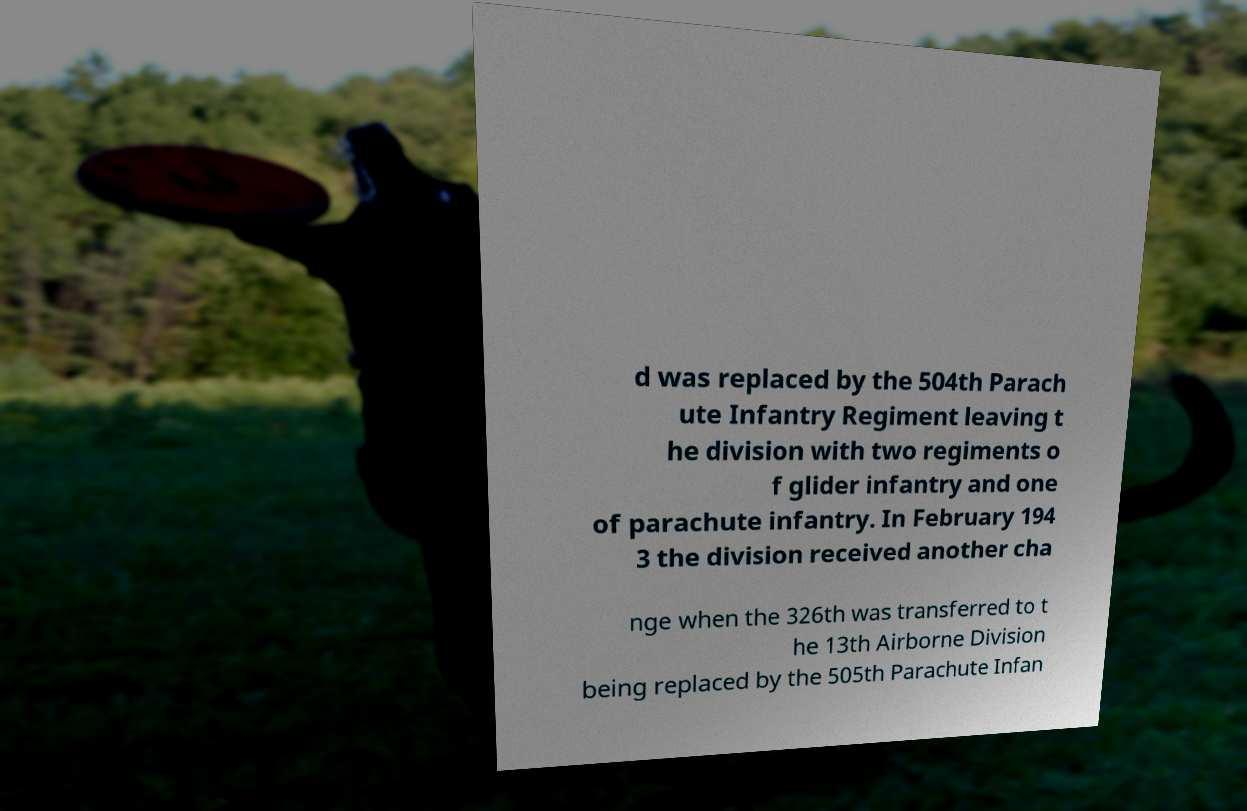For documentation purposes, I need the text within this image transcribed. Could you provide that? d was replaced by the 504th Parach ute Infantry Regiment leaving t he division with two regiments o f glider infantry and one of parachute infantry. In February 194 3 the division received another cha nge when the 326th was transferred to t he 13th Airborne Division being replaced by the 505th Parachute Infan 